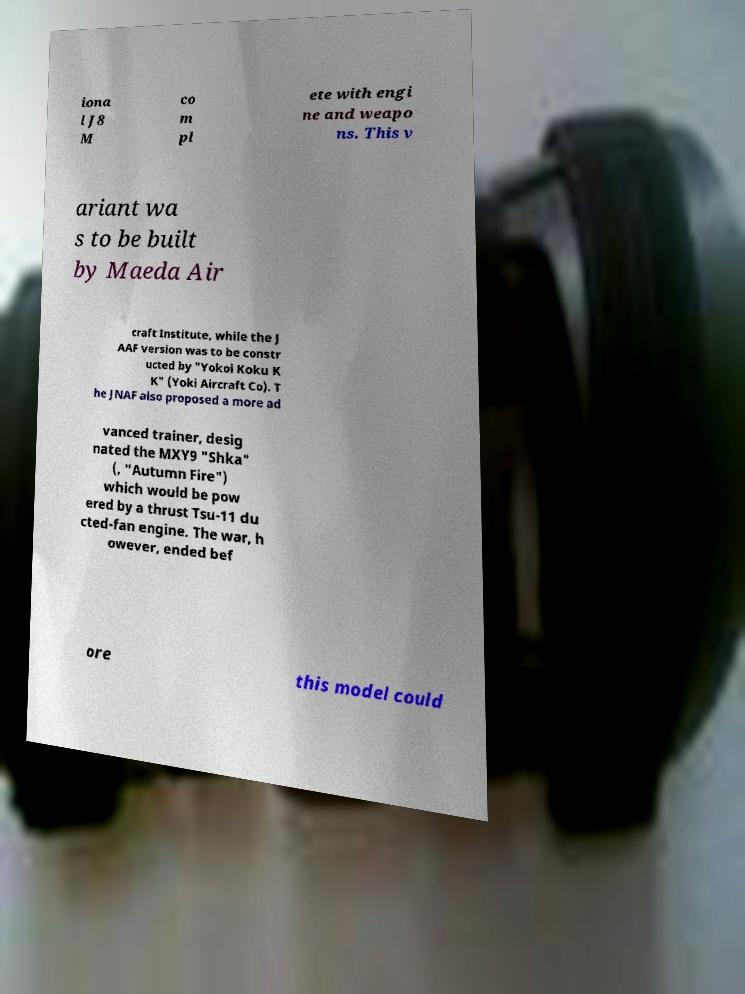For documentation purposes, I need the text within this image transcribed. Could you provide that? iona l J8 M co m pl ete with engi ne and weapo ns. This v ariant wa s to be built by Maeda Air craft Institute, while the J AAF version was to be constr ucted by "Yokoi Koku K K" (Yoki Aircraft Co). T he JNAF also proposed a more ad vanced trainer, desig nated the MXY9 "Shka" (, "Autumn Fire") which would be pow ered by a thrust Tsu-11 du cted-fan engine. The war, h owever, ended bef ore this model could 